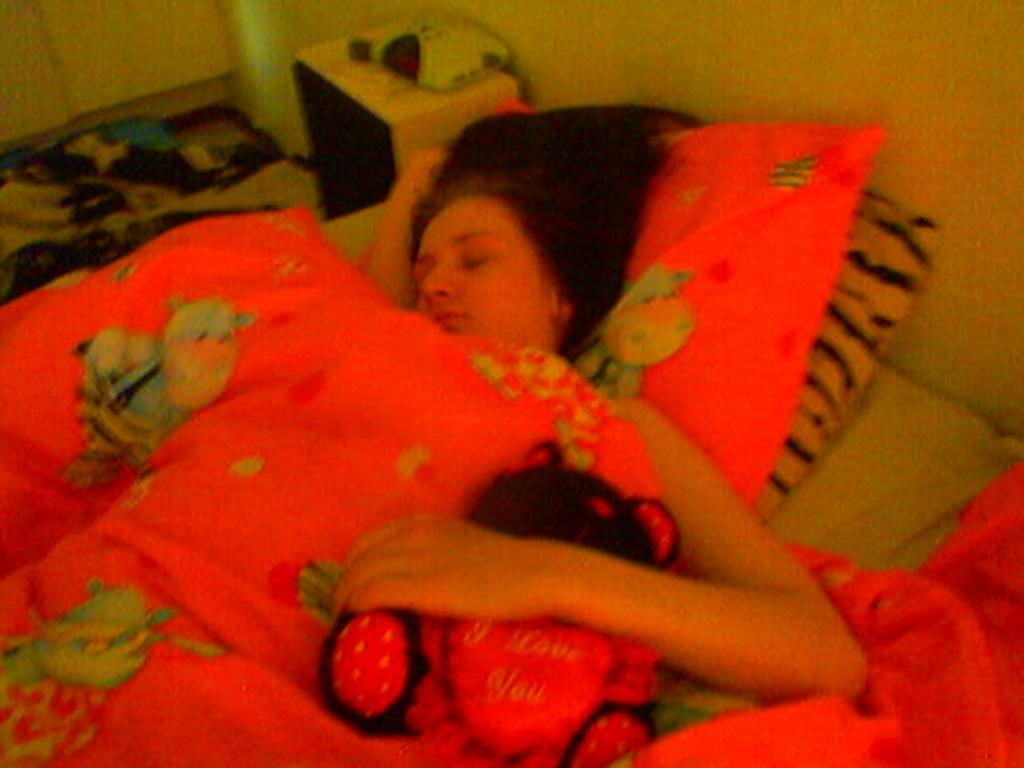Please provide a concise description of this image. In the center of the image we can see a person is lying on a bed and also we can see pillows, blanket. At the top of the image we can see cupboards, clothes and some objects. On the right side of the image there is a wall. 